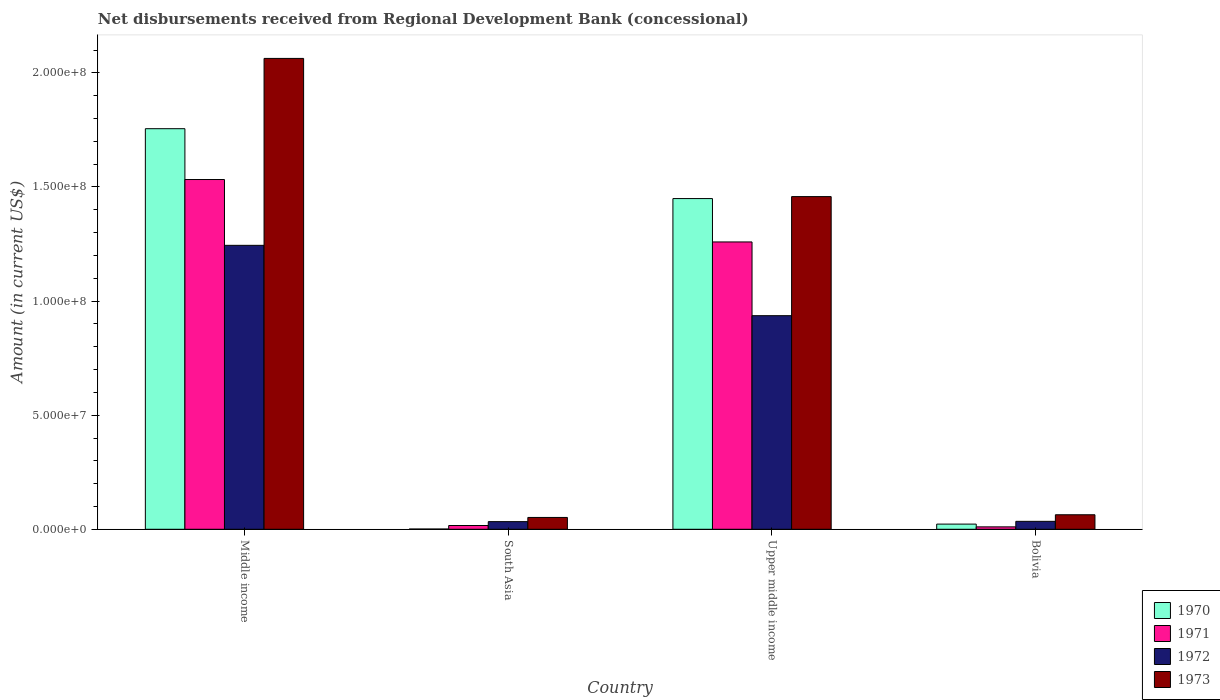How many different coloured bars are there?
Make the answer very short. 4. How many groups of bars are there?
Keep it short and to the point. 4. Are the number of bars on each tick of the X-axis equal?
Ensure brevity in your answer.  Yes. How many bars are there on the 3rd tick from the left?
Your answer should be very brief. 4. What is the label of the 3rd group of bars from the left?
Ensure brevity in your answer.  Upper middle income. In how many cases, is the number of bars for a given country not equal to the number of legend labels?
Offer a very short reply. 0. What is the amount of disbursements received from Regional Development Bank in 1970 in Upper middle income?
Make the answer very short. 1.45e+08. Across all countries, what is the maximum amount of disbursements received from Regional Development Bank in 1973?
Offer a very short reply. 2.06e+08. Across all countries, what is the minimum amount of disbursements received from Regional Development Bank in 1971?
Provide a short and direct response. 1.06e+06. In which country was the amount of disbursements received from Regional Development Bank in 1971 maximum?
Provide a short and direct response. Middle income. In which country was the amount of disbursements received from Regional Development Bank in 1970 minimum?
Offer a very short reply. South Asia. What is the total amount of disbursements received from Regional Development Bank in 1972 in the graph?
Your response must be concise. 2.25e+08. What is the difference between the amount of disbursements received from Regional Development Bank in 1971 in Bolivia and that in South Asia?
Your answer should be very brief. -5.92e+05. What is the difference between the amount of disbursements received from Regional Development Bank in 1971 in Upper middle income and the amount of disbursements received from Regional Development Bank in 1973 in South Asia?
Provide a short and direct response. 1.21e+08. What is the average amount of disbursements received from Regional Development Bank in 1972 per country?
Provide a short and direct response. 5.62e+07. What is the difference between the amount of disbursements received from Regional Development Bank of/in 1970 and amount of disbursements received from Regional Development Bank of/in 1971 in South Asia?
Your answer should be very brief. -1.54e+06. What is the ratio of the amount of disbursements received from Regional Development Bank in 1970 in Middle income to that in Upper middle income?
Offer a terse response. 1.21. What is the difference between the highest and the second highest amount of disbursements received from Regional Development Bank in 1971?
Give a very brief answer. 1.52e+08. What is the difference between the highest and the lowest amount of disbursements received from Regional Development Bank in 1970?
Offer a terse response. 1.75e+08. Is it the case that in every country, the sum of the amount of disbursements received from Regional Development Bank in 1972 and amount of disbursements received from Regional Development Bank in 1973 is greater than the sum of amount of disbursements received from Regional Development Bank in 1970 and amount of disbursements received from Regional Development Bank in 1971?
Give a very brief answer. No. What does the 1st bar from the right in South Asia represents?
Your answer should be very brief. 1973. Is it the case that in every country, the sum of the amount of disbursements received from Regional Development Bank in 1971 and amount of disbursements received from Regional Development Bank in 1970 is greater than the amount of disbursements received from Regional Development Bank in 1972?
Your answer should be very brief. No. Are all the bars in the graph horizontal?
Your answer should be very brief. No. How many countries are there in the graph?
Make the answer very short. 4. What is the difference between two consecutive major ticks on the Y-axis?
Offer a very short reply. 5.00e+07. Are the values on the major ticks of Y-axis written in scientific E-notation?
Your answer should be very brief. Yes. Does the graph contain grids?
Provide a short and direct response. No. How many legend labels are there?
Give a very brief answer. 4. How are the legend labels stacked?
Your answer should be compact. Vertical. What is the title of the graph?
Offer a very short reply. Net disbursements received from Regional Development Bank (concessional). What is the label or title of the Y-axis?
Give a very brief answer. Amount (in current US$). What is the Amount (in current US$) of 1970 in Middle income?
Provide a succinct answer. 1.76e+08. What is the Amount (in current US$) in 1971 in Middle income?
Offer a terse response. 1.53e+08. What is the Amount (in current US$) in 1972 in Middle income?
Offer a very short reply. 1.24e+08. What is the Amount (in current US$) of 1973 in Middle income?
Keep it short and to the point. 2.06e+08. What is the Amount (in current US$) of 1970 in South Asia?
Provide a succinct answer. 1.09e+05. What is the Amount (in current US$) of 1971 in South Asia?
Provide a succinct answer. 1.65e+06. What is the Amount (in current US$) of 1972 in South Asia?
Provide a succinct answer. 3.35e+06. What is the Amount (in current US$) of 1973 in South Asia?
Provide a short and direct response. 5.18e+06. What is the Amount (in current US$) in 1970 in Upper middle income?
Offer a very short reply. 1.45e+08. What is the Amount (in current US$) in 1971 in Upper middle income?
Keep it short and to the point. 1.26e+08. What is the Amount (in current US$) of 1972 in Upper middle income?
Make the answer very short. 9.36e+07. What is the Amount (in current US$) of 1973 in Upper middle income?
Your response must be concise. 1.46e+08. What is the Amount (in current US$) of 1970 in Bolivia?
Your answer should be very brief. 2.27e+06. What is the Amount (in current US$) of 1971 in Bolivia?
Your answer should be compact. 1.06e+06. What is the Amount (in current US$) in 1972 in Bolivia?
Offer a terse response. 3.48e+06. What is the Amount (in current US$) of 1973 in Bolivia?
Your answer should be compact. 6.36e+06. Across all countries, what is the maximum Amount (in current US$) in 1970?
Keep it short and to the point. 1.76e+08. Across all countries, what is the maximum Amount (in current US$) of 1971?
Your answer should be very brief. 1.53e+08. Across all countries, what is the maximum Amount (in current US$) of 1972?
Your answer should be very brief. 1.24e+08. Across all countries, what is the maximum Amount (in current US$) in 1973?
Give a very brief answer. 2.06e+08. Across all countries, what is the minimum Amount (in current US$) of 1970?
Make the answer very short. 1.09e+05. Across all countries, what is the minimum Amount (in current US$) in 1971?
Offer a very short reply. 1.06e+06. Across all countries, what is the minimum Amount (in current US$) of 1972?
Give a very brief answer. 3.35e+06. Across all countries, what is the minimum Amount (in current US$) in 1973?
Provide a succinct answer. 5.18e+06. What is the total Amount (in current US$) in 1970 in the graph?
Ensure brevity in your answer.  3.23e+08. What is the total Amount (in current US$) of 1971 in the graph?
Give a very brief answer. 2.82e+08. What is the total Amount (in current US$) in 1972 in the graph?
Ensure brevity in your answer.  2.25e+08. What is the total Amount (in current US$) in 1973 in the graph?
Provide a succinct answer. 3.64e+08. What is the difference between the Amount (in current US$) of 1970 in Middle income and that in South Asia?
Keep it short and to the point. 1.75e+08. What is the difference between the Amount (in current US$) of 1971 in Middle income and that in South Asia?
Ensure brevity in your answer.  1.52e+08. What is the difference between the Amount (in current US$) in 1972 in Middle income and that in South Asia?
Provide a succinct answer. 1.21e+08. What is the difference between the Amount (in current US$) in 1973 in Middle income and that in South Asia?
Keep it short and to the point. 2.01e+08. What is the difference between the Amount (in current US$) of 1970 in Middle income and that in Upper middle income?
Your answer should be compact. 3.06e+07. What is the difference between the Amount (in current US$) of 1971 in Middle income and that in Upper middle income?
Provide a succinct answer. 2.74e+07. What is the difference between the Amount (in current US$) in 1972 in Middle income and that in Upper middle income?
Keep it short and to the point. 3.08e+07. What is the difference between the Amount (in current US$) in 1973 in Middle income and that in Upper middle income?
Keep it short and to the point. 6.06e+07. What is the difference between the Amount (in current US$) of 1970 in Middle income and that in Bolivia?
Provide a short and direct response. 1.73e+08. What is the difference between the Amount (in current US$) of 1971 in Middle income and that in Bolivia?
Provide a short and direct response. 1.52e+08. What is the difference between the Amount (in current US$) of 1972 in Middle income and that in Bolivia?
Your answer should be very brief. 1.21e+08. What is the difference between the Amount (in current US$) in 1973 in Middle income and that in Bolivia?
Offer a very short reply. 2.00e+08. What is the difference between the Amount (in current US$) in 1970 in South Asia and that in Upper middle income?
Provide a short and direct response. -1.45e+08. What is the difference between the Amount (in current US$) of 1971 in South Asia and that in Upper middle income?
Offer a very short reply. -1.24e+08. What is the difference between the Amount (in current US$) in 1972 in South Asia and that in Upper middle income?
Provide a short and direct response. -9.03e+07. What is the difference between the Amount (in current US$) in 1973 in South Asia and that in Upper middle income?
Offer a very short reply. -1.41e+08. What is the difference between the Amount (in current US$) of 1970 in South Asia and that in Bolivia?
Your answer should be very brief. -2.16e+06. What is the difference between the Amount (in current US$) of 1971 in South Asia and that in Bolivia?
Offer a very short reply. 5.92e+05. What is the difference between the Amount (in current US$) of 1972 in South Asia and that in Bolivia?
Your answer should be very brief. -1.30e+05. What is the difference between the Amount (in current US$) of 1973 in South Asia and that in Bolivia?
Ensure brevity in your answer.  -1.18e+06. What is the difference between the Amount (in current US$) of 1970 in Upper middle income and that in Bolivia?
Ensure brevity in your answer.  1.43e+08. What is the difference between the Amount (in current US$) of 1971 in Upper middle income and that in Bolivia?
Your response must be concise. 1.25e+08. What is the difference between the Amount (in current US$) of 1972 in Upper middle income and that in Bolivia?
Keep it short and to the point. 9.01e+07. What is the difference between the Amount (in current US$) of 1973 in Upper middle income and that in Bolivia?
Give a very brief answer. 1.39e+08. What is the difference between the Amount (in current US$) in 1970 in Middle income and the Amount (in current US$) in 1971 in South Asia?
Give a very brief answer. 1.74e+08. What is the difference between the Amount (in current US$) in 1970 in Middle income and the Amount (in current US$) in 1972 in South Asia?
Ensure brevity in your answer.  1.72e+08. What is the difference between the Amount (in current US$) of 1970 in Middle income and the Amount (in current US$) of 1973 in South Asia?
Your answer should be compact. 1.70e+08. What is the difference between the Amount (in current US$) in 1971 in Middle income and the Amount (in current US$) in 1972 in South Asia?
Ensure brevity in your answer.  1.50e+08. What is the difference between the Amount (in current US$) in 1971 in Middle income and the Amount (in current US$) in 1973 in South Asia?
Provide a succinct answer. 1.48e+08. What is the difference between the Amount (in current US$) of 1972 in Middle income and the Amount (in current US$) of 1973 in South Asia?
Ensure brevity in your answer.  1.19e+08. What is the difference between the Amount (in current US$) in 1970 in Middle income and the Amount (in current US$) in 1971 in Upper middle income?
Your answer should be compact. 4.96e+07. What is the difference between the Amount (in current US$) in 1970 in Middle income and the Amount (in current US$) in 1972 in Upper middle income?
Your answer should be compact. 8.19e+07. What is the difference between the Amount (in current US$) of 1970 in Middle income and the Amount (in current US$) of 1973 in Upper middle income?
Your response must be concise. 2.98e+07. What is the difference between the Amount (in current US$) of 1971 in Middle income and the Amount (in current US$) of 1972 in Upper middle income?
Provide a succinct answer. 5.97e+07. What is the difference between the Amount (in current US$) in 1971 in Middle income and the Amount (in current US$) in 1973 in Upper middle income?
Ensure brevity in your answer.  7.49e+06. What is the difference between the Amount (in current US$) of 1972 in Middle income and the Amount (in current US$) of 1973 in Upper middle income?
Your response must be concise. -2.14e+07. What is the difference between the Amount (in current US$) of 1970 in Middle income and the Amount (in current US$) of 1971 in Bolivia?
Give a very brief answer. 1.74e+08. What is the difference between the Amount (in current US$) in 1970 in Middle income and the Amount (in current US$) in 1972 in Bolivia?
Ensure brevity in your answer.  1.72e+08. What is the difference between the Amount (in current US$) of 1970 in Middle income and the Amount (in current US$) of 1973 in Bolivia?
Give a very brief answer. 1.69e+08. What is the difference between the Amount (in current US$) in 1971 in Middle income and the Amount (in current US$) in 1972 in Bolivia?
Ensure brevity in your answer.  1.50e+08. What is the difference between the Amount (in current US$) of 1971 in Middle income and the Amount (in current US$) of 1973 in Bolivia?
Provide a short and direct response. 1.47e+08. What is the difference between the Amount (in current US$) of 1972 in Middle income and the Amount (in current US$) of 1973 in Bolivia?
Your response must be concise. 1.18e+08. What is the difference between the Amount (in current US$) in 1970 in South Asia and the Amount (in current US$) in 1971 in Upper middle income?
Offer a terse response. -1.26e+08. What is the difference between the Amount (in current US$) of 1970 in South Asia and the Amount (in current US$) of 1972 in Upper middle income?
Your answer should be compact. -9.35e+07. What is the difference between the Amount (in current US$) of 1970 in South Asia and the Amount (in current US$) of 1973 in Upper middle income?
Keep it short and to the point. -1.46e+08. What is the difference between the Amount (in current US$) in 1971 in South Asia and the Amount (in current US$) in 1972 in Upper middle income?
Ensure brevity in your answer.  -9.20e+07. What is the difference between the Amount (in current US$) of 1971 in South Asia and the Amount (in current US$) of 1973 in Upper middle income?
Your answer should be very brief. -1.44e+08. What is the difference between the Amount (in current US$) of 1972 in South Asia and the Amount (in current US$) of 1973 in Upper middle income?
Provide a succinct answer. -1.42e+08. What is the difference between the Amount (in current US$) in 1970 in South Asia and the Amount (in current US$) in 1971 in Bolivia?
Give a very brief answer. -9.49e+05. What is the difference between the Amount (in current US$) of 1970 in South Asia and the Amount (in current US$) of 1972 in Bolivia?
Give a very brief answer. -3.37e+06. What is the difference between the Amount (in current US$) in 1970 in South Asia and the Amount (in current US$) in 1973 in Bolivia?
Provide a short and direct response. -6.25e+06. What is the difference between the Amount (in current US$) in 1971 in South Asia and the Amount (in current US$) in 1972 in Bolivia?
Provide a succinct answer. -1.83e+06. What is the difference between the Amount (in current US$) of 1971 in South Asia and the Amount (in current US$) of 1973 in Bolivia?
Offer a terse response. -4.71e+06. What is the difference between the Amount (in current US$) in 1972 in South Asia and the Amount (in current US$) in 1973 in Bolivia?
Your answer should be compact. -3.01e+06. What is the difference between the Amount (in current US$) of 1970 in Upper middle income and the Amount (in current US$) of 1971 in Bolivia?
Give a very brief answer. 1.44e+08. What is the difference between the Amount (in current US$) of 1970 in Upper middle income and the Amount (in current US$) of 1972 in Bolivia?
Give a very brief answer. 1.41e+08. What is the difference between the Amount (in current US$) in 1970 in Upper middle income and the Amount (in current US$) in 1973 in Bolivia?
Give a very brief answer. 1.39e+08. What is the difference between the Amount (in current US$) of 1971 in Upper middle income and the Amount (in current US$) of 1972 in Bolivia?
Make the answer very short. 1.22e+08. What is the difference between the Amount (in current US$) of 1971 in Upper middle income and the Amount (in current US$) of 1973 in Bolivia?
Your response must be concise. 1.20e+08. What is the difference between the Amount (in current US$) of 1972 in Upper middle income and the Amount (in current US$) of 1973 in Bolivia?
Make the answer very short. 8.72e+07. What is the average Amount (in current US$) in 1970 per country?
Keep it short and to the point. 8.07e+07. What is the average Amount (in current US$) in 1971 per country?
Provide a short and direct response. 7.05e+07. What is the average Amount (in current US$) in 1972 per country?
Give a very brief answer. 5.62e+07. What is the average Amount (in current US$) of 1973 per country?
Offer a terse response. 9.09e+07. What is the difference between the Amount (in current US$) of 1970 and Amount (in current US$) of 1971 in Middle income?
Your answer should be very brief. 2.23e+07. What is the difference between the Amount (in current US$) of 1970 and Amount (in current US$) of 1972 in Middle income?
Ensure brevity in your answer.  5.11e+07. What is the difference between the Amount (in current US$) of 1970 and Amount (in current US$) of 1973 in Middle income?
Offer a very short reply. -3.08e+07. What is the difference between the Amount (in current US$) of 1971 and Amount (in current US$) of 1972 in Middle income?
Provide a short and direct response. 2.88e+07. What is the difference between the Amount (in current US$) in 1971 and Amount (in current US$) in 1973 in Middle income?
Your answer should be compact. -5.31e+07. What is the difference between the Amount (in current US$) of 1972 and Amount (in current US$) of 1973 in Middle income?
Offer a terse response. -8.19e+07. What is the difference between the Amount (in current US$) in 1970 and Amount (in current US$) in 1971 in South Asia?
Offer a terse response. -1.54e+06. What is the difference between the Amount (in current US$) in 1970 and Amount (in current US$) in 1972 in South Asia?
Provide a succinct answer. -3.24e+06. What is the difference between the Amount (in current US$) of 1970 and Amount (in current US$) of 1973 in South Asia?
Your answer should be compact. -5.08e+06. What is the difference between the Amount (in current US$) of 1971 and Amount (in current US$) of 1972 in South Asia?
Your response must be concise. -1.70e+06. What is the difference between the Amount (in current US$) of 1971 and Amount (in current US$) of 1973 in South Asia?
Ensure brevity in your answer.  -3.53e+06. What is the difference between the Amount (in current US$) of 1972 and Amount (in current US$) of 1973 in South Asia?
Your answer should be compact. -1.83e+06. What is the difference between the Amount (in current US$) in 1970 and Amount (in current US$) in 1971 in Upper middle income?
Offer a terse response. 1.90e+07. What is the difference between the Amount (in current US$) in 1970 and Amount (in current US$) in 1972 in Upper middle income?
Give a very brief answer. 5.13e+07. What is the difference between the Amount (in current US$) of 1970 and Amount (in current US$) of 1973 in Upper middle income?
Offer a terse response. -8.58e+05. What is the difference between the Amount (in current US$) of 1971 and Amount (in current US$) of 1972 in Upper middle income?
Give a very brief answer. 3.23e+07. What is the difference between the Amount (in current US$) of 1971 and Amount (in current US$) of 1973 in Upper middle income?
Offer a terse response. -1.99e+07. What is the difference between the Amount (in current US$) of 1972 and Amount (in current US$) of 1973 in Upper middle income?
Give a very brief answer. -5.22e+07. What is the difference between the Amount (in current US$) of 1970 and Amount (in current US$) of 1971 in Bolivia?
Give a very brief answer. 1.21e+06. What is the difference between the Amount (in current US$) of 1970 and Amount (in current US$) of 1972 in Bolivia?
Provide a succinct answer. -1.21e+06. What is the difference between the Amount (in current US$) in 1970 and Amount (in current US$) in 1973 in Bolivia?
Ensure brevity in your answer.  -4.09e+06. What is the difference between the Amount (in current US$) in 1971 and Amount (in current US$) in 1972 in Bolivia?
Your response must be concise. -2.42e+06. What is the difference between the Amount (in current US$) in 1971 and Amount (in current US$) in 1973 in Bolivia?
Provide a succinct answer. -5.30e+06. What is the difference between the Amount (in current US$) in 1972 and Amount (in current US$) in 1973 in Bolivia?
Provide a short and direct response. -2.88e+06. What is the ratio of the Amount (in current US$) in 1970 in Middle income to that in South Asia?
Give a very brief answer. 1610.58. What is the ratio of the Amount (in current US$) in 1971 in Middle income to that in South Asia?
Your answer should be very brief. 92.89. What is the ratio of the Amount (in current US$) of 1972 in Middle income to that in South Asia?
Your answer should be compact. 37.14. What is the ratio of the Amount (in current US$) of 1973 in Middle income to that in South Asia?
Your response must be concise. 39.8. What is the ratio of the Amount (in current US$) of 1970 in Middle income to that in Upper middle income?
Offer a terse response. 1.21. What is the ratio of the Amount (in current US$) of 1971 in Middle income to that in Upper middle income?
Your answer should be very brief. 1.22. What is the ratio of the Amount (in current US$) of 1972 in Middle income to that in Upper middle income?
Ensure brevity in your answer.  1.33. What is the ratio of the Amount (in current US$) in 1973 in Middle income to that in Upper middle income?
Offer a very short reply. 1.42. What is the ratio of the Amount (in current US$) in 1970 in Middle income to that in Bolivia?
Provide a short and direct response. 77.34. What is the ratio of the Amount (in current US$) in 1971 in Middle income to that in Bolivia?
Your answer should be very brief. 144.87. What is the ratio of the Amount (in current US$) in 1972 in Middle income to that in Bolivia?
Provide a succinct answer. 35.76. What is the ratio of the Amount (in current US$) of 1973 in Middle income to that in Bolivia?
Ensure brevity in your answer.  32.44. What is the ratio of the Amount (in current US$) in 1970 in South Asia to that in Upper middle income?
Your answer should be compact. 0. What is the ratio of the Amount (in current US$) in 1971 in South Asia to that in Upper middle income?
Your response must be concise. 0.01. What is the ratio of the Amount (in current US$) in 1972 in South Asia to that in Upper middle income?
Ensure brevity in your answer.  0.04. What is the ratio of the Amount (in current US$) of 1973 in South Asia to that in Upper middle income?
Provide a succinct answer. 0.04. What is the ratio of the Amount (in current US$) of 1970 in South Asia to that in Bolivia?
Your answer should be very brief. 0.05. What is the ratio of the Amount (in current US$) of 1971 in South Asia to that in Bolivia?
Give a very brief answer. 1.56. What is the ratio of the Amount (in current US$) of 1972 in South Asia to that in Bolivia?
Offer a very short reply. 0.96. What is the ratio of the Amount (in current US$) of 1973 in South Asia to that in Bolivia?
Offer a very short reply. 0.82. What is the ratio of the Amount (in current US$) of 1970 in Upper middle income to that in Bolivia?
Offer a terse response. 63.85. What is the ratio of the Amount (in current US$) in 1971 in Upper middle income to that in Bolivia?
Ensure brevity in your answer.  119.02. What is the ratio of the Amount (in current US$) of 1972 in Upper middle income to that in Bolivia?
Your response must be concise. 26.9. What is the ratio of the Amount (in current US$) in 1973 in Upper middle income to that in Bolivia?
Provide a succinct answer. 22.92. What is the difference between the highest and the second highest Amount (in current US$) of 1970?
Ensure brevity in your answer.  3.06e+07. What is the difference between the highest and the second highest Amount (in current US$) of 1971?
Your response must be concise. 2.74e+07. What is the difference between the highest and the second highest Amount (in current US$) in 1972?
Your answer should be compact. 3.08e+07. What is the difference between the highest and the second highest Amount (in current US$) in 1973?
Your response must be concise. 6.06e+07. What is the difference between the highest and the lowest Amount (in current US$) of 1970?
Provide a short and direct response. 1.75e+08. What is the difference between the highest and the lowest Amount (in current US$) in 1971?
Offer a very short reply. 1.52e+08. What is the difference between the highest and the lowest Amount (in current US$) of 1972?
Ensure brevity in your answer.  1.21e+08. What is the difference between the highest and the lowest Amount (in current US$) in 1973?
Provide a short and direct response. 2.01e+08. 